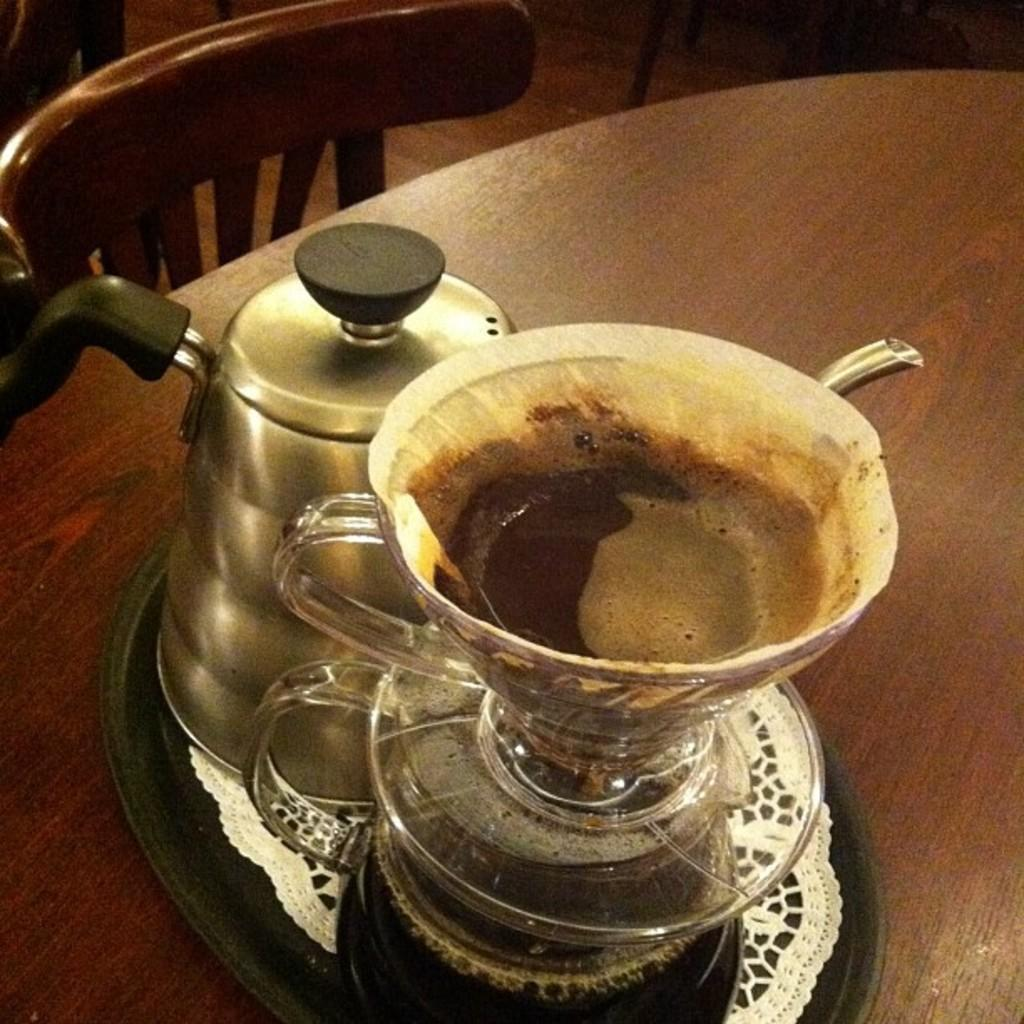What objects are on the black tray in the foreground of the image? There are two jars on a black tray in the foreground in the image. What is covering one of the jars? There is a cup placed over one of the jars. What type of surface is the tray placed on? The tray is placed on a wooden table. What type of furniture is visible in the image? There is a chair visible at the top of the image. What type of battle is taking place in the image? There is no battle present in the image; it features two jars on a black tray with a cup covering one of them. Is there a crib visible in the image? There is no crib present in the image. 